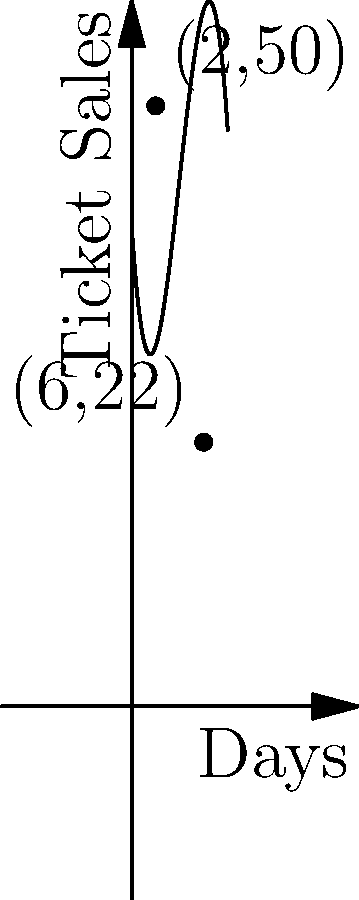The polynomial graph shows the ticket sales trend for our Celtic music tour over 8 days. If the function is given by $f(x) = -0.5x^3 + 6x^2 - 15x + 40$, where $x$ represents the number of days and $f(x)$ represents the number of tickets sold, on which day did we sell the maximum number of tickets? To find the day with maximum ticket sales, we need to follow these steps:

1) The maximum point of the function occurs where its derivative equals zero. Let's find the derivative:

   $f'(x) = -1.5x^2 + 12x - 15$

2) Set the derivative to zero and solve for x:

   $-1.5x^2 + 12x - 15 = 0$

3) This is a quadratic equation. We can solve it using the quadratic formula:
   
   $x = \frac{-b \pm \sqrt{b^2 - 4ac}}{2a}$

   Where $a = -1.5$, $b = 12$, and $c = -15$

4) Plugging in these values:

   $x = \frac{-12 \pm \sqrt{12^2 - 4(-1.5)(-15)}}{2(-1.5)}$

5) Simplifying:

   $x = \frac{-12 \pm \sqrt{144 - 90}}{-3} = \frac{-12 \pm \sqrt{54}}{-3} = \frac{-12 \pm 3\sqrt{6}}{-3}$

6) This gives us two solutions:

   $x_1 = 2$ and $x_2 = 6$

7) To determine which of these is the maximum (rather than the minimum), we can check the second derivative:

   $f''(x) = -3x + 12$

8) At $x = 2$: $f''(2) = -3(2) + 12 = 6 > 0$, indicating a local minimum
   At $x = 6$: $f''(6) = -3(6) + 12 = -6 < 0$, indicating a local maximum

Therefore, the maximum occurs at $x = 2$, which corresponds to the 2nd day of the tour.
Answer: Day 2 